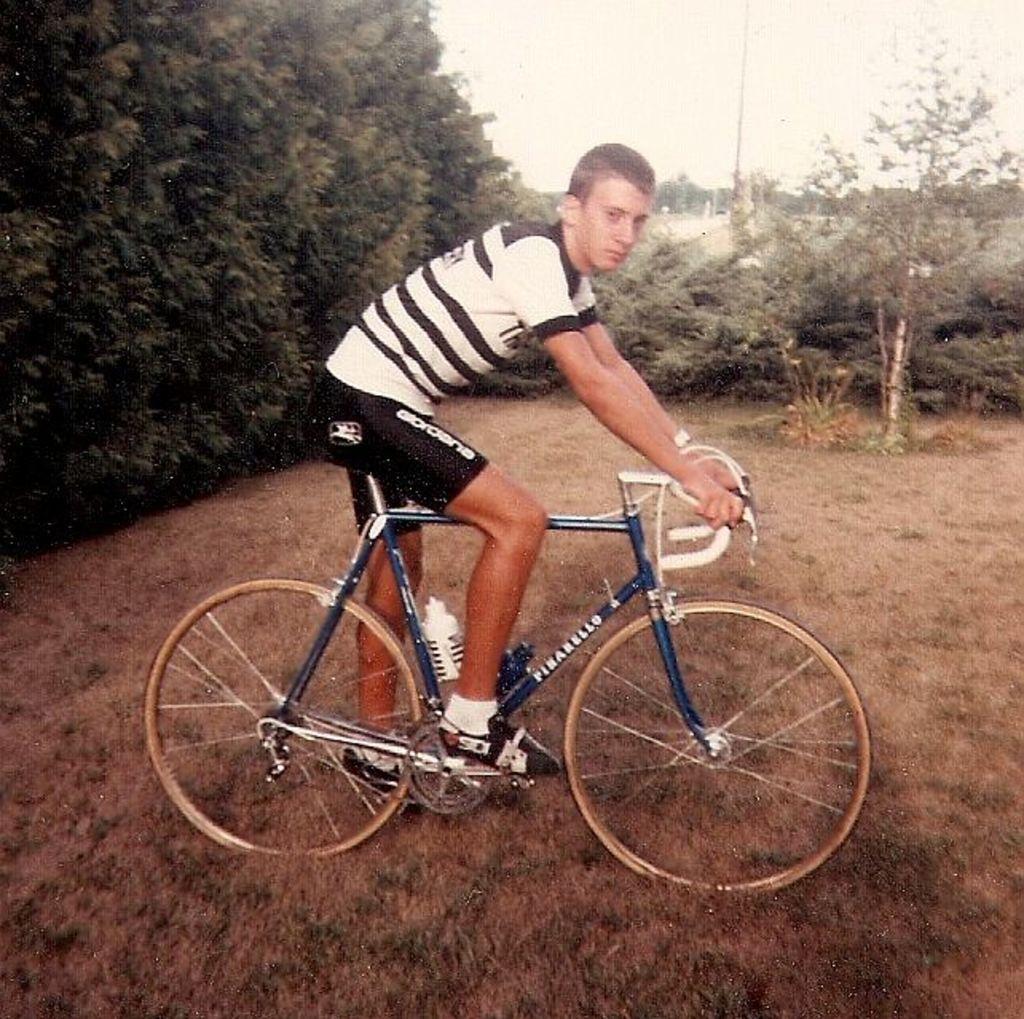Describe this image in one or two sentences. In this image I can see a person is sitting on the bicycle and it is in blue color. He is wearing a black and white t-shirt and the shoes. In the back there are trees and the sky. 